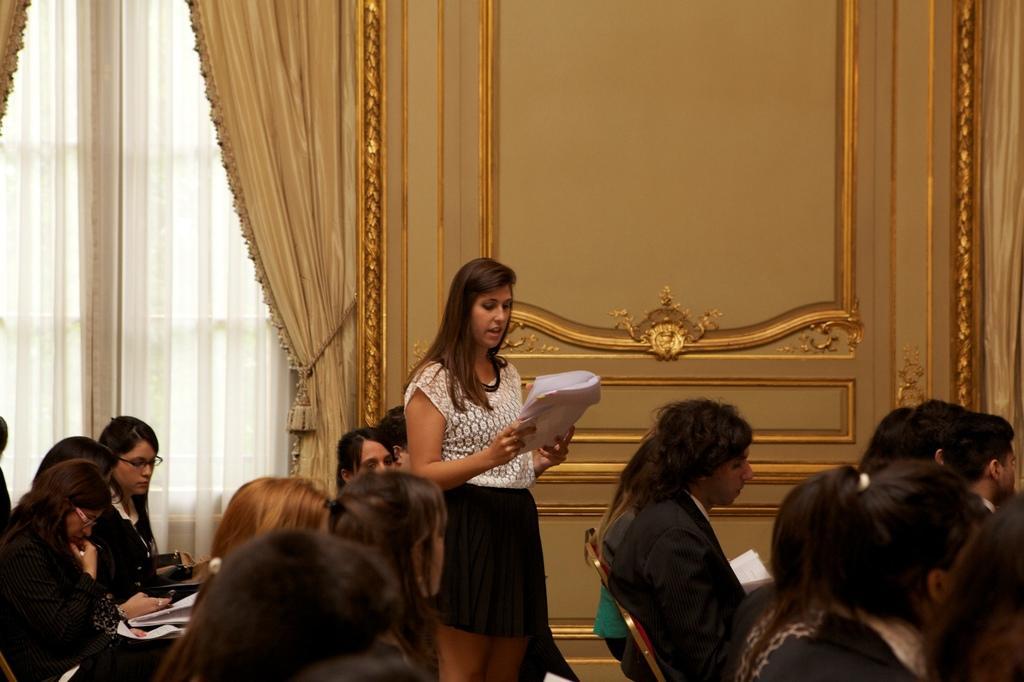Please provide a concise description of this image. In this picture I can see group of people sitting on the chairs, there is a woman standing and holding papers, and in the background there are curtains and a wall. 